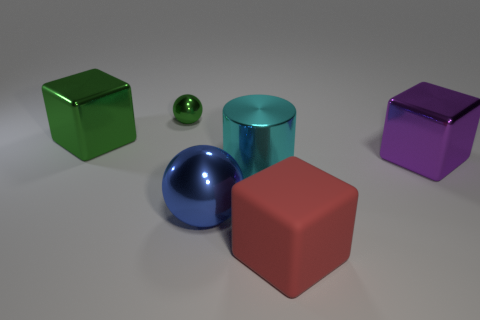Is there anything else that has the same shape as the cyan thing?
Give a very brief answer. No. Are there any other things that are the same size as the green metal ball?
Offer a very short reply. No. Is the number of large cylinders less than the number of large brown rubber cubes?
Your answer should be very brief. No. What material is the large block that is in front of the purple block?
Offer a terse response. Rubber. What is the material of the other green block that is the same size as the matte block?
Your answer should be very brief. Metal. There is a green thing that is behind the green cube that is on the left side of the green metal thing that is behind the green metal block; what is its material?
Give a very brief answer. Metal. Do the shiny block to the right of the red thing and the big green thing have the same size?
Give a very brief answer. Yes. Are there more big blue metal balls than gray blocks?
Ensure brevity in your answer.  Yes. How many large objects are either cyan things or purple metal objects?
Offer a terse response. 2. What number of other objects are the same color as the tiny ball?
Offer a terse response. 1. 